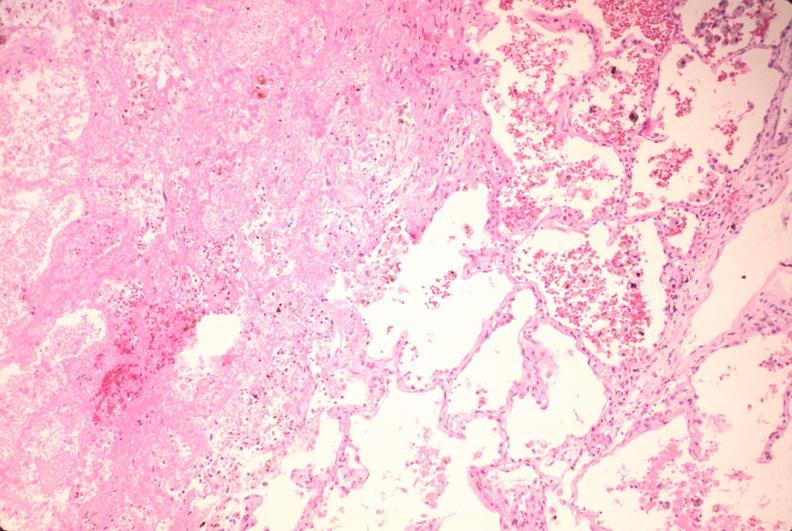s coronary atherosclerosis present?
Answer the question using a single word or phrase. No 